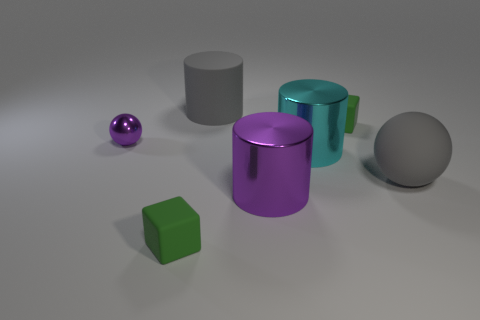How many matte objects are on the left side of the big cyan shiny cylinder and behind the purple shiny sphere?
Offer a very short reply. 1. Are there any large green cubes made of the same material as the gray sphere?
Your answer should be compact. No. What material is the tiny block that is right of the large thing behind the small purple ball made of?
Your answer should be very brief. Rubber. Is the number of gray objects left of the cyan metal cylinder the same as the number of large matte spheres behind the big gray rubber cylinder?
Your answer should be very brief. No. Is the shape of the big purple object the same as the cyan thing?
Your answer should be very brief. Yes. The object that is to the right of the cyan cylinder and behind the small purple shiny object is made of what material?
Provide a short and direct response. Rubber. How many large purple metallic things are the same shape as the cyan object?
Give a very brief answer. 1. What is the size of the matte object that is in front of the purple metallic object that is on the right side of the cube that is in front of the big cyan shiny thing?
Your answer should be compact. Small. Is the number of big metal objects to the left of the large purple metal cylinder greater than the number of matte balls?
Provide a short and direct response. No. Is there a tiny green shiny cube?
Ensure brevity in your answer.  No. 